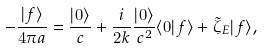<formula> <loc_0><loc_0><loc_500><loc_500>- \frac { | f \rangle } { 4 \pi a } = \frac { | 0 \rangle } { c } + \frac { i } { 2 k } \frac { | 0 \rangle } { c ^ { 2 } } \langle 0 | f \rangle + \tilde { \zeta } _ { E } | f \rangle ,</formula> 